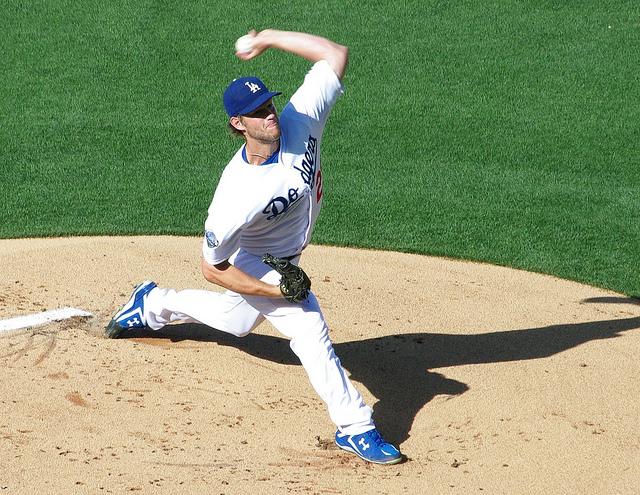What color is the hat?
Keep it brief. Blue. Is this a pro sports team?
Write a very short answer. Yes. Which city does this team represent?
Quick response, please. Los angeles. 